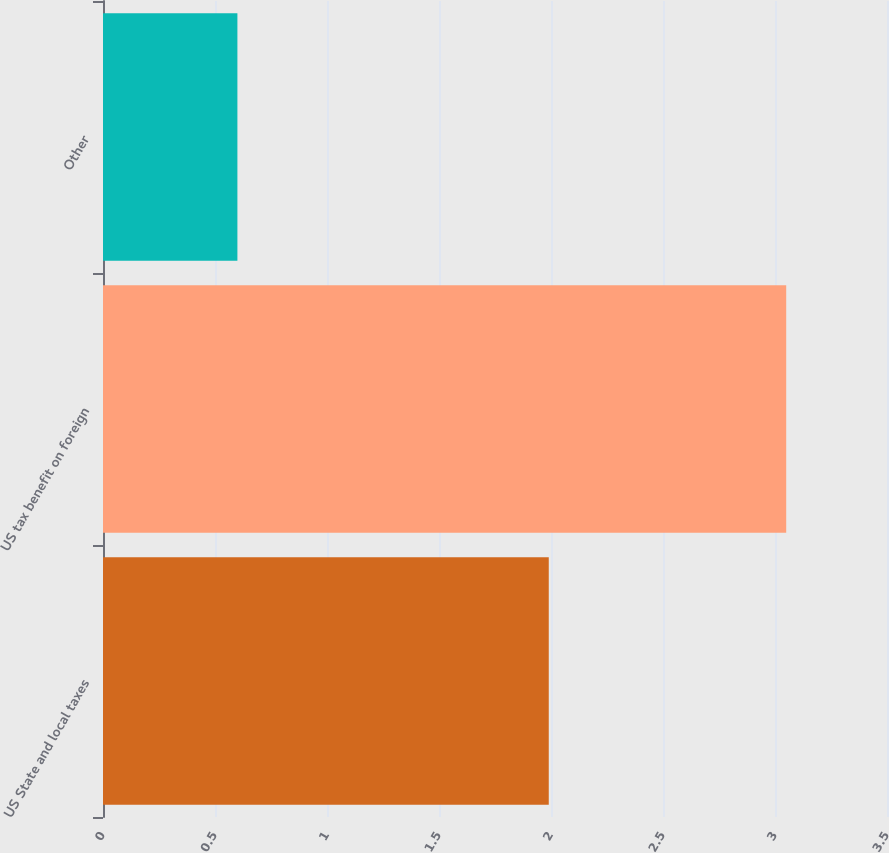<chart> <loc_0><loc_0><loc_500><loc_500><bar_chart><fcel>US State and local taxes<fcel>US tax benefit on foreign<fcel>Other<nl><fcel>1.99<fcel>3.05<fcel>0.6<nl></chart> 